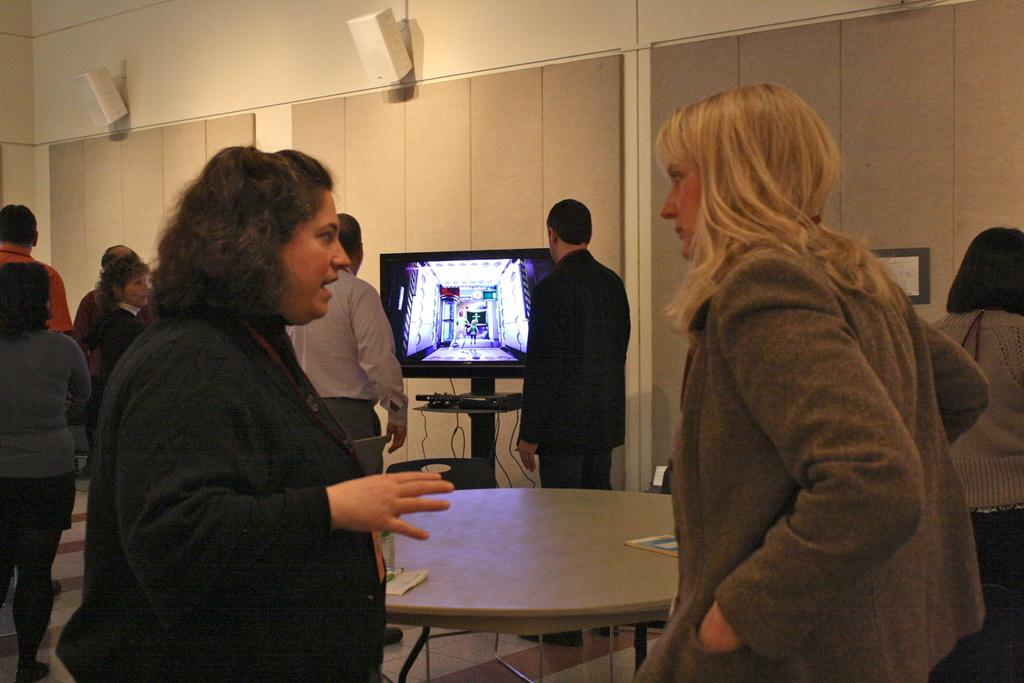How many people are present in the room? There are many people in the room. What type of screen is present in the room? There is an LED screen in the room. What is located in front of the people in the room? There is a table in front of the people. Can you see a loaf of bread on the table in the image? There is no loaf of bread present on the table in the image. Is there a snail crawling on the LED screen in the image? There is no snail present on the LED screen in the image. 